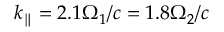<formula> <loc_0><loc_0><loc_500><loc_500>k _ { \| } = 2 . 1 \Omega _ { 1 } / c = 1 . 8 \Omega _ { 2 } / c</formula> 